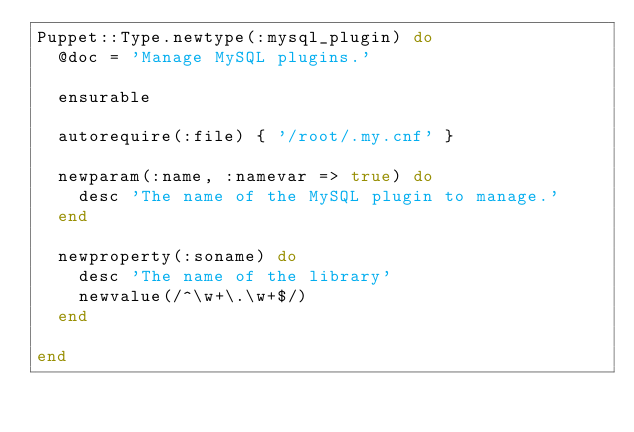<code> <loc_0><loc_0><loc_500><loc_500><_Ruby_>Puppet::Type.newtype(:mysql_plugin) do
  @doc = 'Manage MySQL plugins.'

  ensurable

  autorequire(:file) { '/root/.my.cnf' }

  newparam(:name, :namevar => true) do
    desc 'The name of the MySQL plugin to manage.'
  end

  newproperty(:soname) do
    desc 'The name of the library'
    newvalue(/^\w+\.\w+$/)
  end

end
</code> 